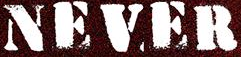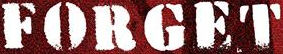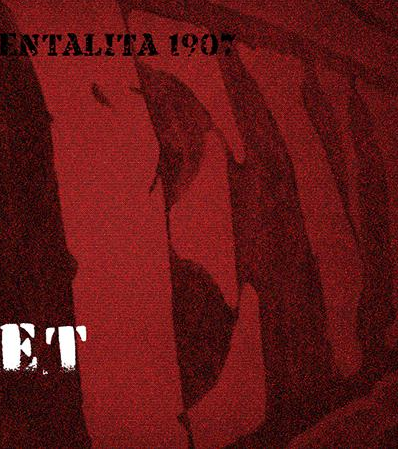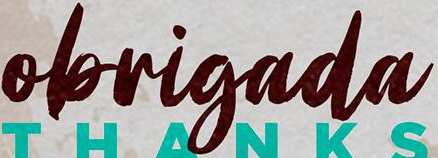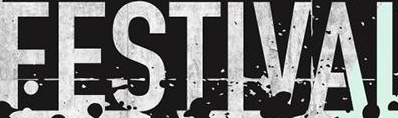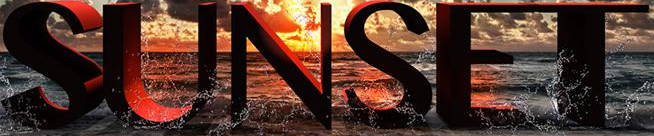What text is displayed in these images sequentially, separated by a semicolon? NEVER; FORGET; EV; obrigada; FESTIVAI; SUNSET 